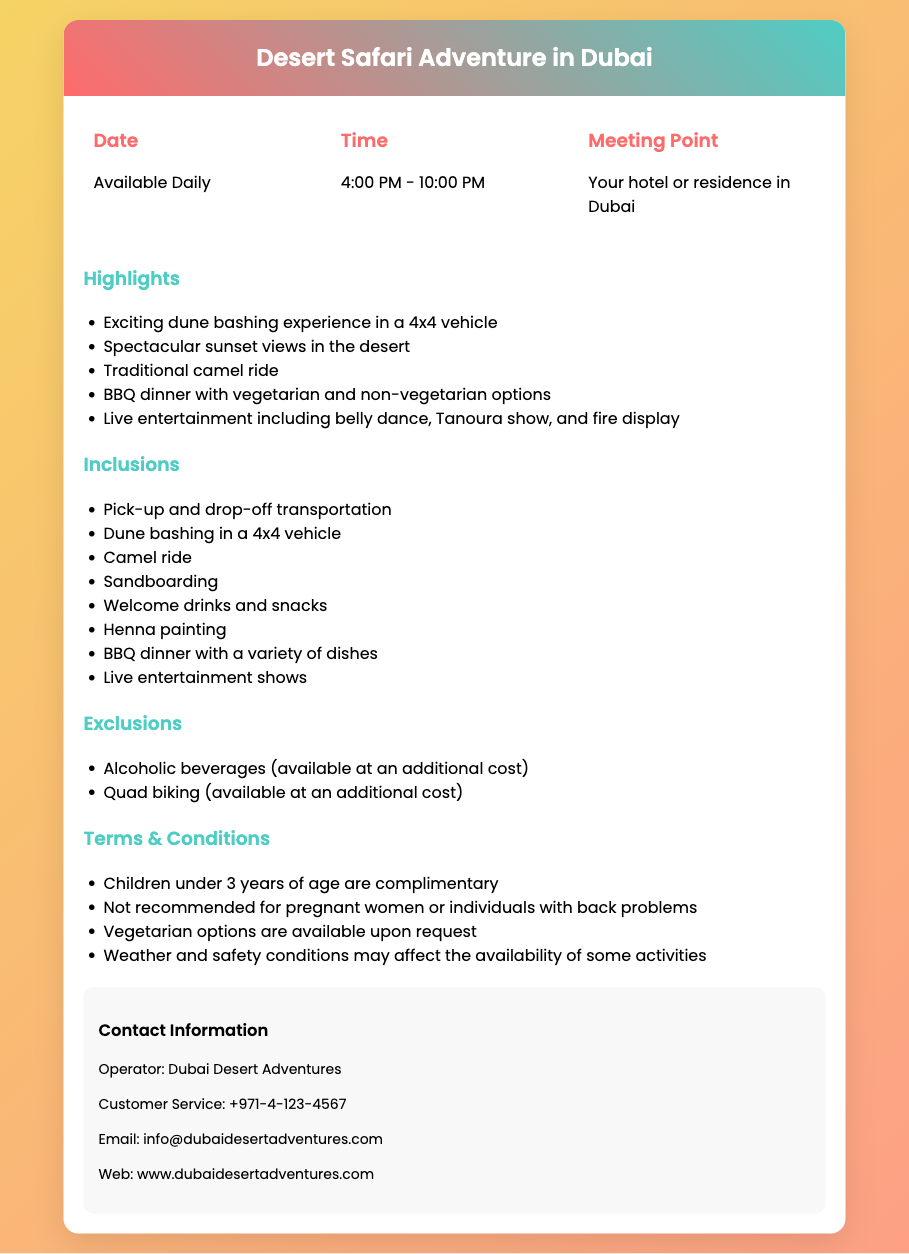What time does the Desert Safari Adventure start? The document states the adventure runs from 4:00 PM to 10:00 PM.
Answer: 4:00 PM What is included in the BBQ dinner? The document mentions a variety of dishes are part of the BBQ dinner.
Answer: Variety of dishes Is sandboarding included in the package? The document lists sandboarding as one of the inclusions.
Answer: Yes What is the name of the operator? The document provides the name of the operator as Dubai Desert Adventures.
Answer: Dubai Desert Adventures How long does the Desert Safari Adventure last? The adventure is scheduled from 4:00 PM to 10:00 PM, indicating a duration of 6 hours.
Answer: 6 hours Are alcoholic beverages included in the package? The document notes that alcoholic beverages are available at an additional cost and not included.
Answer: No Is this adventure suitable for pregnant women? The terms and conditions mention it is not recommended for pregnant women.
Answer: No What type of entertainment is provided during the dinner? The highlights section mentions live entertainment including belly dance and fire display.
Answer: Belly dance, fire display What is the contact email for customer service? The document specifies the email address as info@dubaidesertadventures.com.
Answer: info@dubaidesertadventures.com What is the meeting point for the adventure? The document states the meeting point is at your hotel or residence in Dubai.
Answer: Your hotel or residence in Dubai 